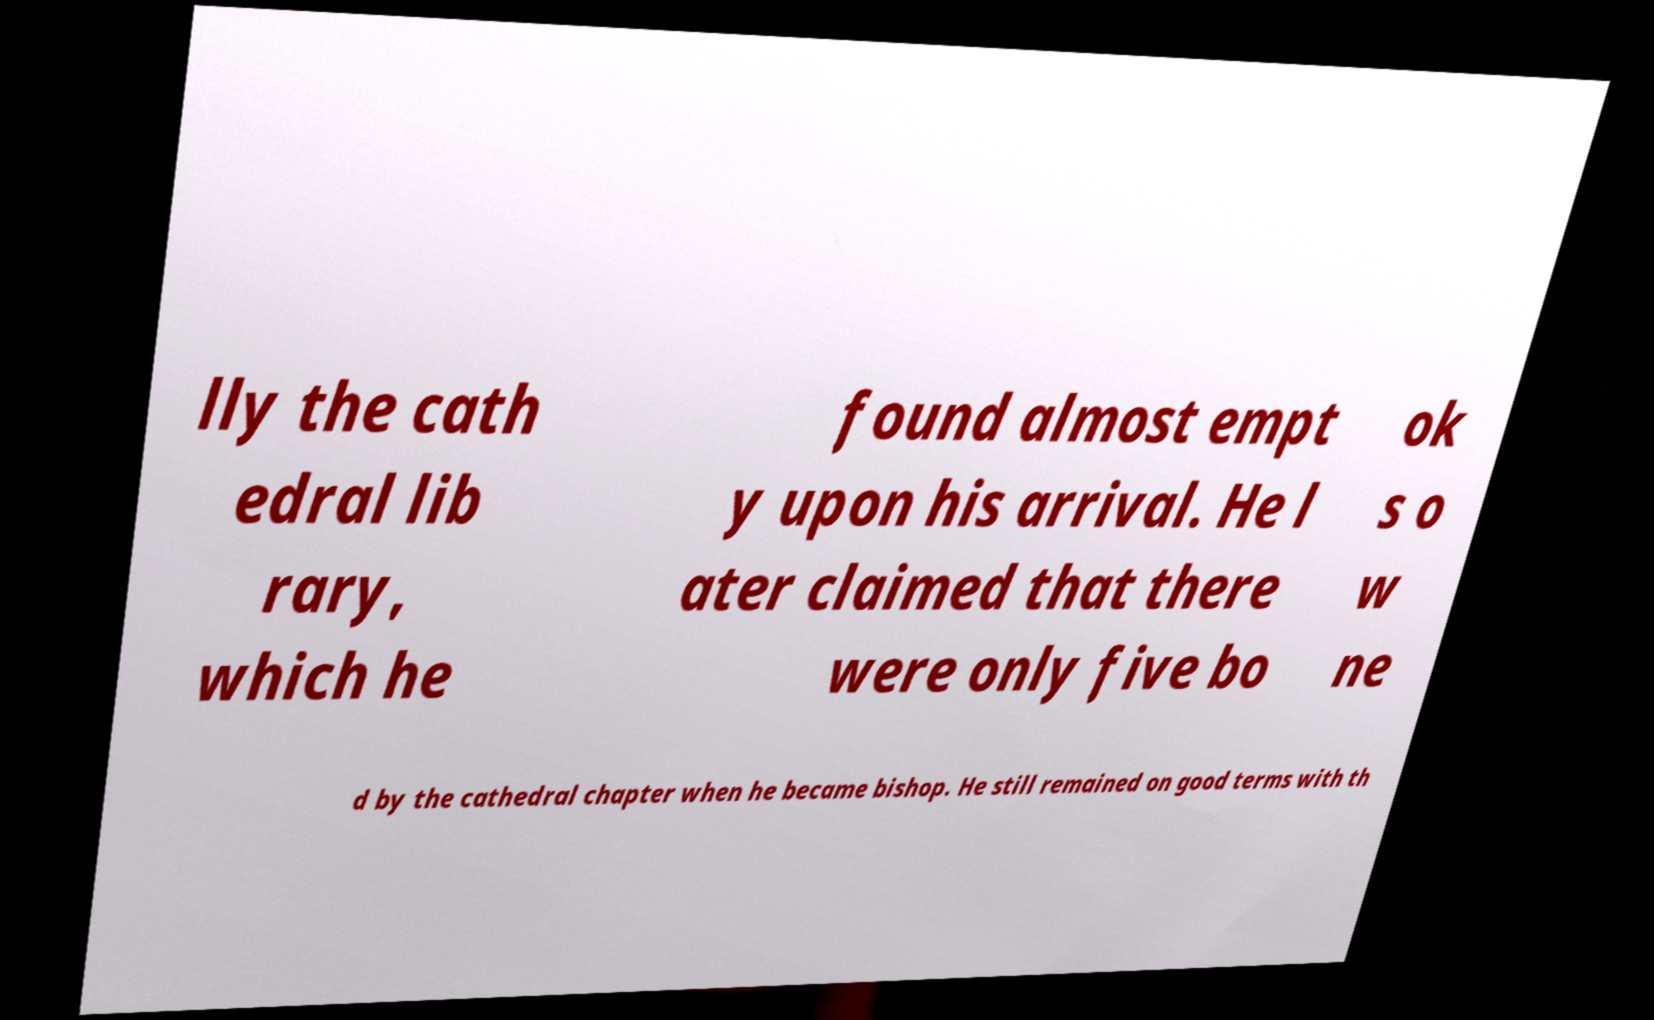For documentation purposes, I need the text within this image transcribed. Could you provide that? lly the cath edral lib rary, which he found almost empt y upon his arrival. He l ater claimed that there were only five bo ok s o w ne d by the cathedral chapter when he became bishop. He still remained on good terms with th 